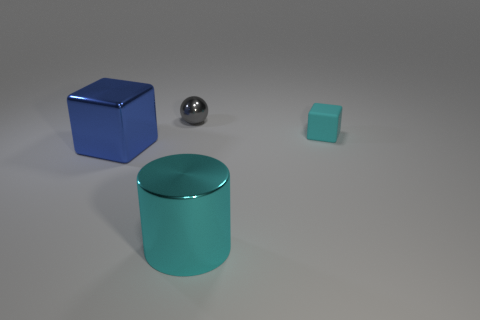Is there anything else that has the same material as the cyan block?
Provide a short and direct response. No. What is the size of the rubber cube that is the same color as the large cylinder?
Provide a succinct answer. Small. What number of large cylinders are the same material as the small cyan block?
Keep it short and to the point. 0. There is a large shiny object that is the same color as the rubber cube; what is its shape?
Your answer should be very brief. Cylinder. There is a object that is in front of the big object that is on the left side of the big cyan metallic cylinder; how big is it?
Offer a very short reply. Large. Does the large metallic thing on the left side of the cylinder have the same shape as the cyan thing that is behind the large shiny cube?
Keep it short and to the point. Yes. Is the number of things behind the blue metal object the same as the number of tiny objects?
Offer a very short reply. Yes. What color is the tiny object that is the same shape as the large blue thing?
Keep it short and to the point. Cyan. Are the big thing to the left of the big shiny cylinder and the big cylinder made of the same material?
Ensure brevity in your answer.  Yes. What number of large objects are either cyan metallic objects or brown metallic balls?
Offer a terse response. 1. 